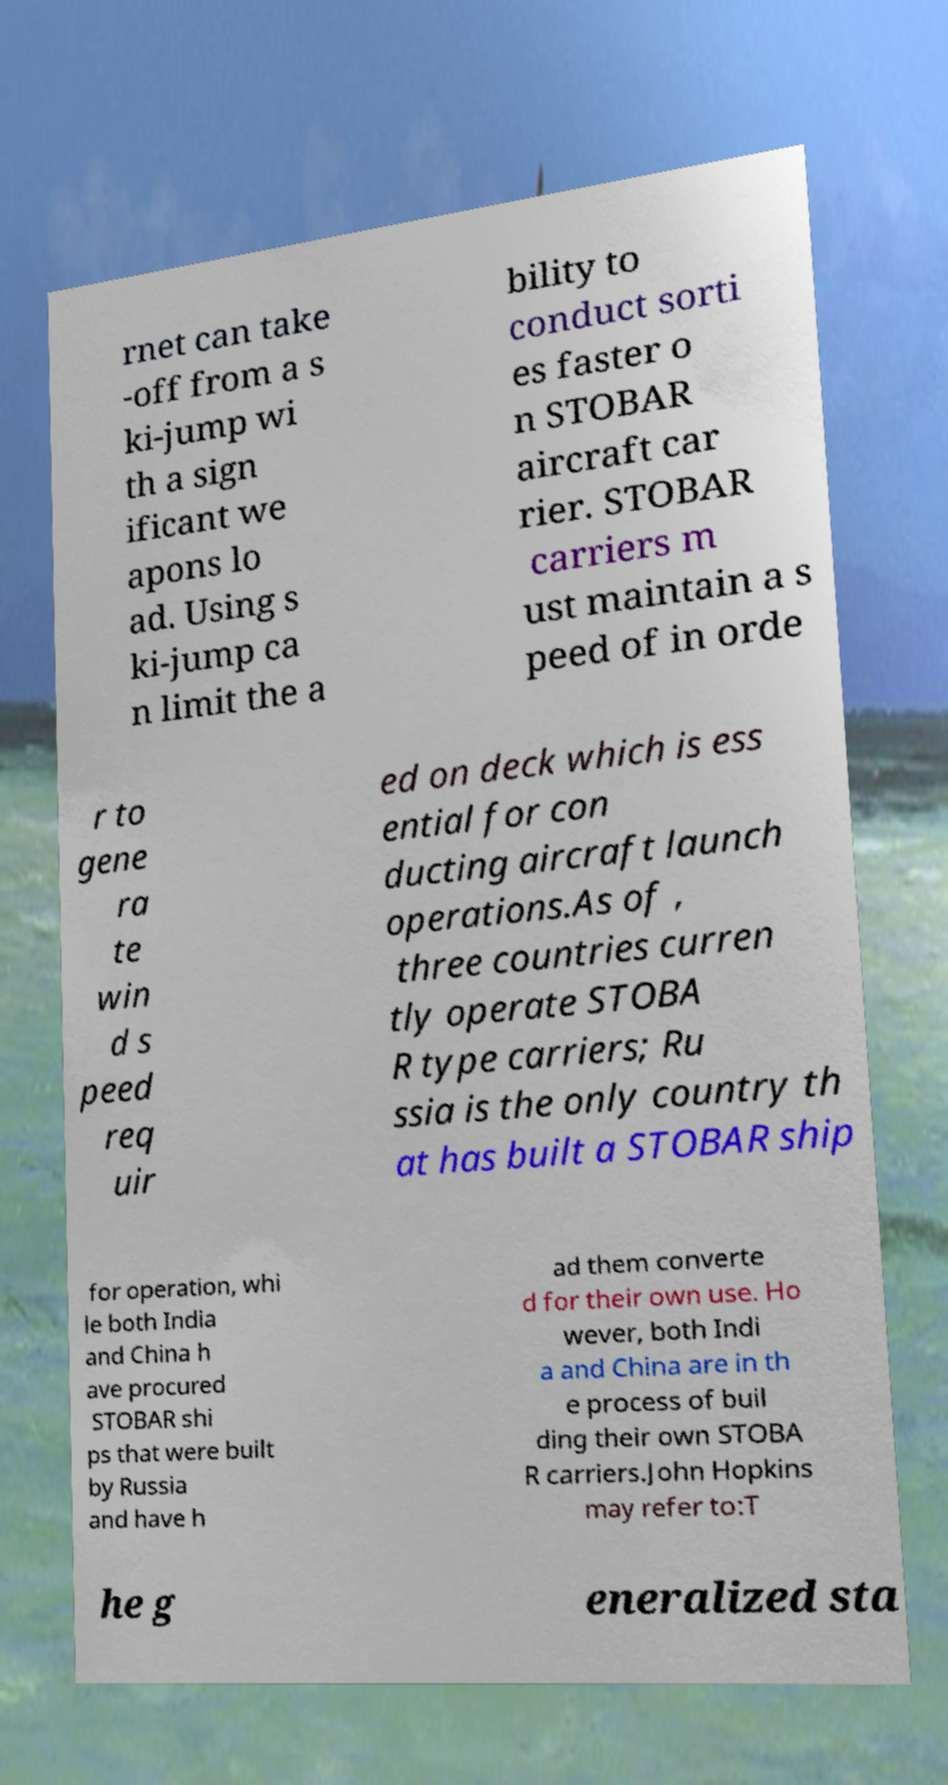Could you extract and type out the text from this image? rnet can take -off from a s ki-jump wi th a sign ificant we apons lo ad. Using s ki-jump ca n limit the a bility to conduct sorti es faster o n STOBAR aircraft car rier. STOBAR carriers m ust maintain a s peed of in orde r to gene ra te win d s peed req uir ed on deck which is ess ential for con ducting aircraft launch operations.As of , three countries curren tly operate STOBA R type carriers; Ru ssia is the only country th at has built a STOBAR ship for operation, whi le both India and China h ave procured STOBAR shi ps that were built by Russia and have h ad them converte d for their own use. Ho wever, both Indi a and China are in th e process of buil ding their own STOBA R carriers.John Hopkins may refer to:T he g eneralized sta 